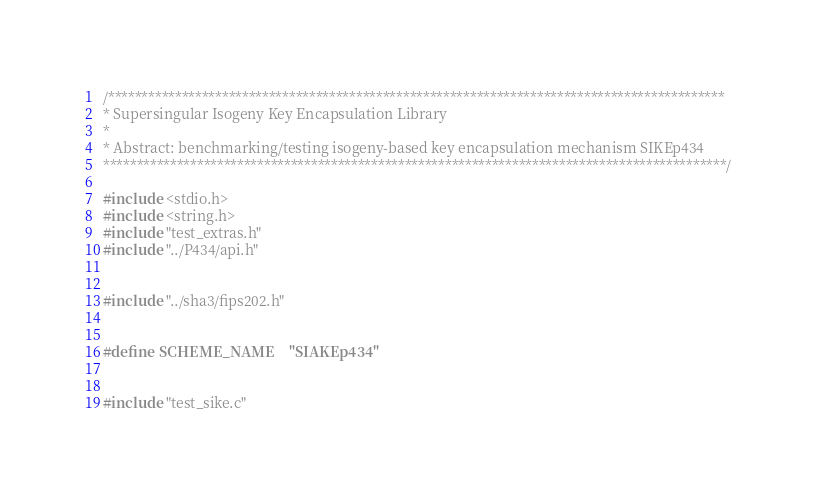Convert code to text. <code><loc_0><loc_0><loc_500><loc_500><_C_>/********************************************************************************************
* Supersingular Isogeny Key Encapsulation Library
*
* Abstract: benchmarking/testing isogeny-based key encapsulation mechanism SIKEp434
*********************************************************************************************/ 

#include <stdio.h>
#include <string.h>
#include "test_extras.h"
#include "../P434/api.h"


#include "../sha3/fips202.h"


#define SCHEME_NAME    "SIAKEp434"


#include "test_sike.c"</code> 